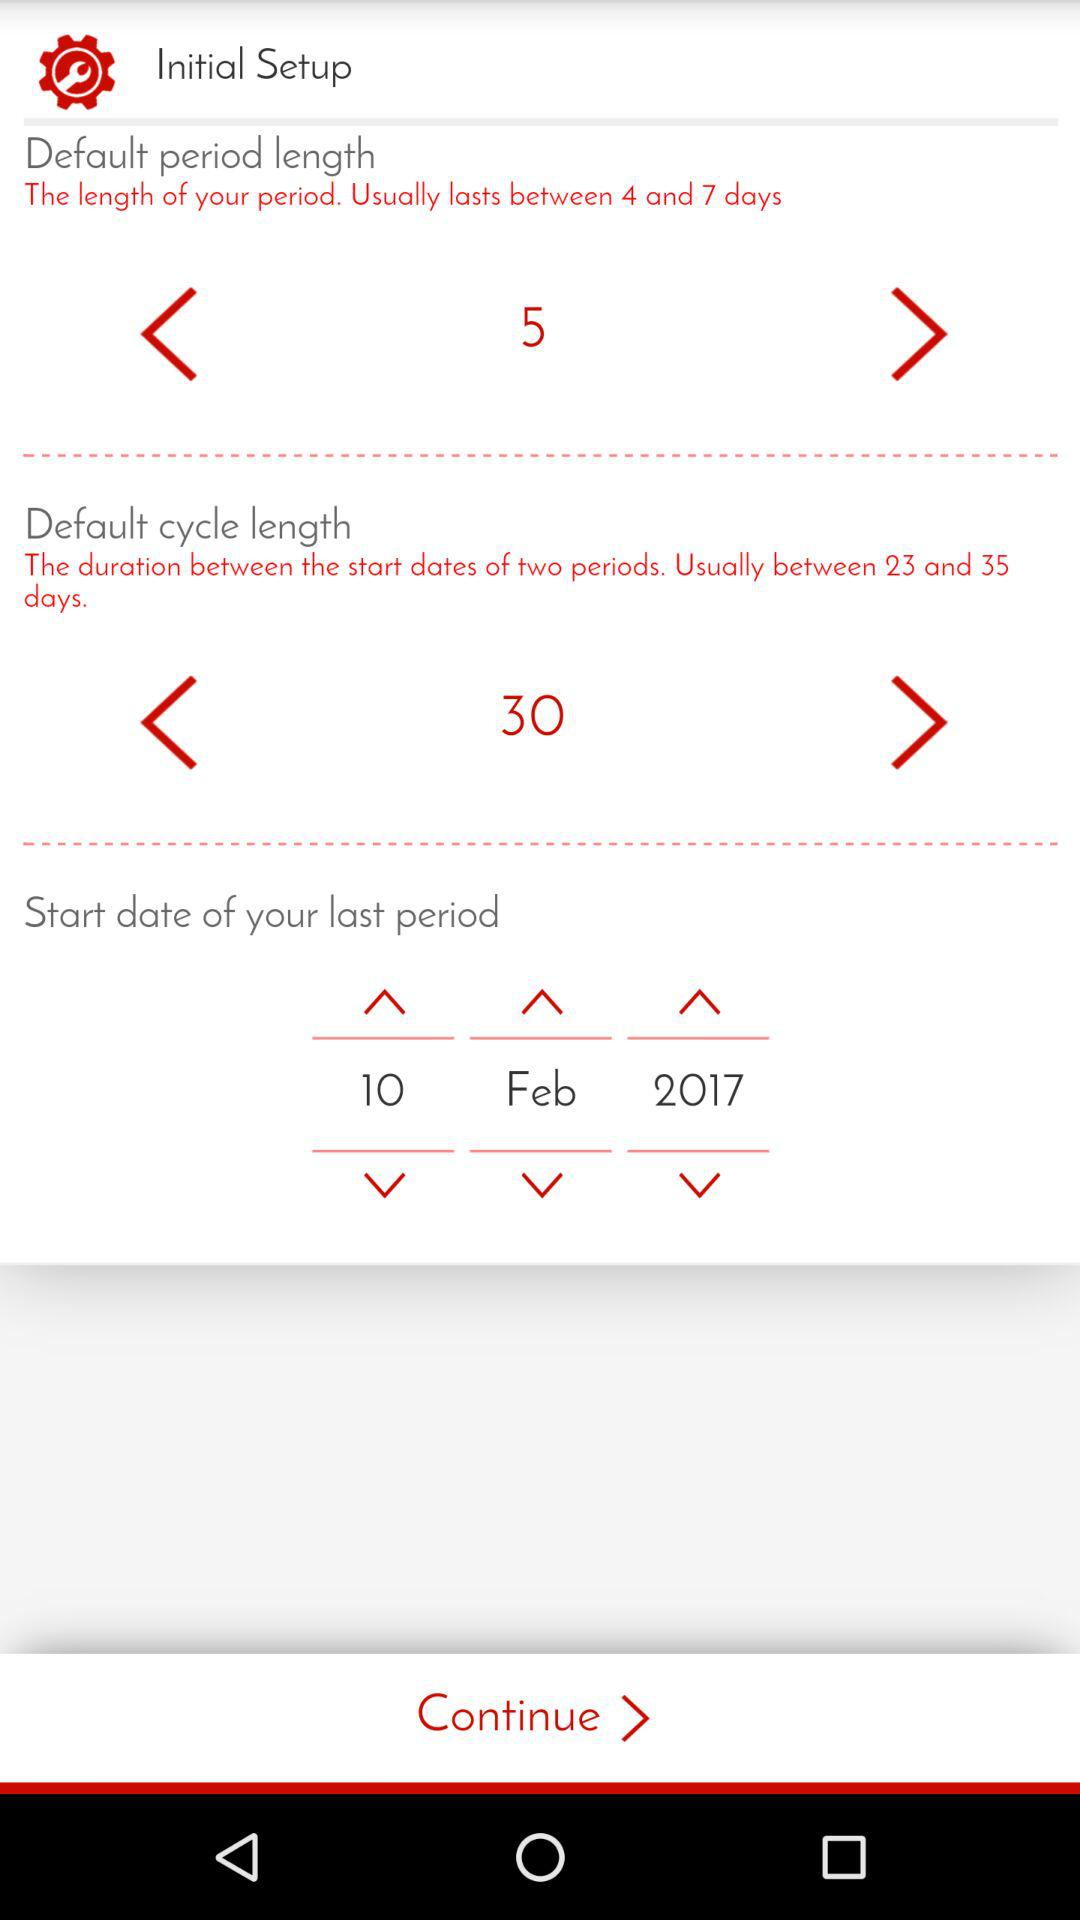What is the default cycle length? The default cycle length is 30. 